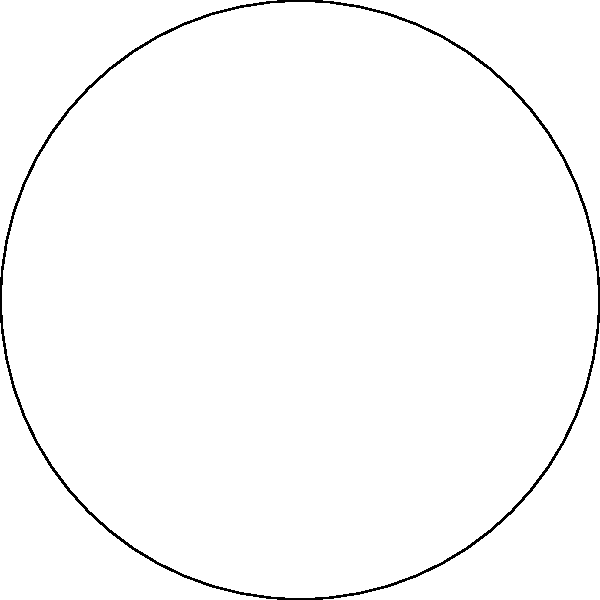In your favorite retro racing game, you're designing a circular track with a radius of 300 meters. The start line is at point A, and the finish line is at point B, forming a 120° angle at the center O. What is the length of the arc AB that represents the race distance? Let's approach this step-by-step, just like we used to figure out game mechanics in the good old days:

1) First, recall the formula for arc length:
   Arc length = $\frac{\theta}{360°} \cdot 2\pi r$
   Where $\theta$ is the central angle in degrees, and $r$ is the radius.

2) We're given:
   - Radius (r) = 300 meters
   - Central angle ($\theta$) = 120°

3) Let's plug these into our formula:
   Arc length = $\frac{120°}{360°} \cdot 2\pi \cdot 300$

4) Simplify the fraction:
   Arc length = $\frac{1}{3} \cdot 2\pi \cdot 300$

5) Calculate:
   Arc length = $\frac{2\pi \cdot 300}{3}$
               = $200\pi$ meters

6) If we want to approximate this:
   $200\pi \approx 628.32$ meters

So, just like in those classic racing games where tracks had specific lengths, this arc is about 628.32 meters long.
Answer: $200\pi$ meters (or approximately 628.32 meters) 